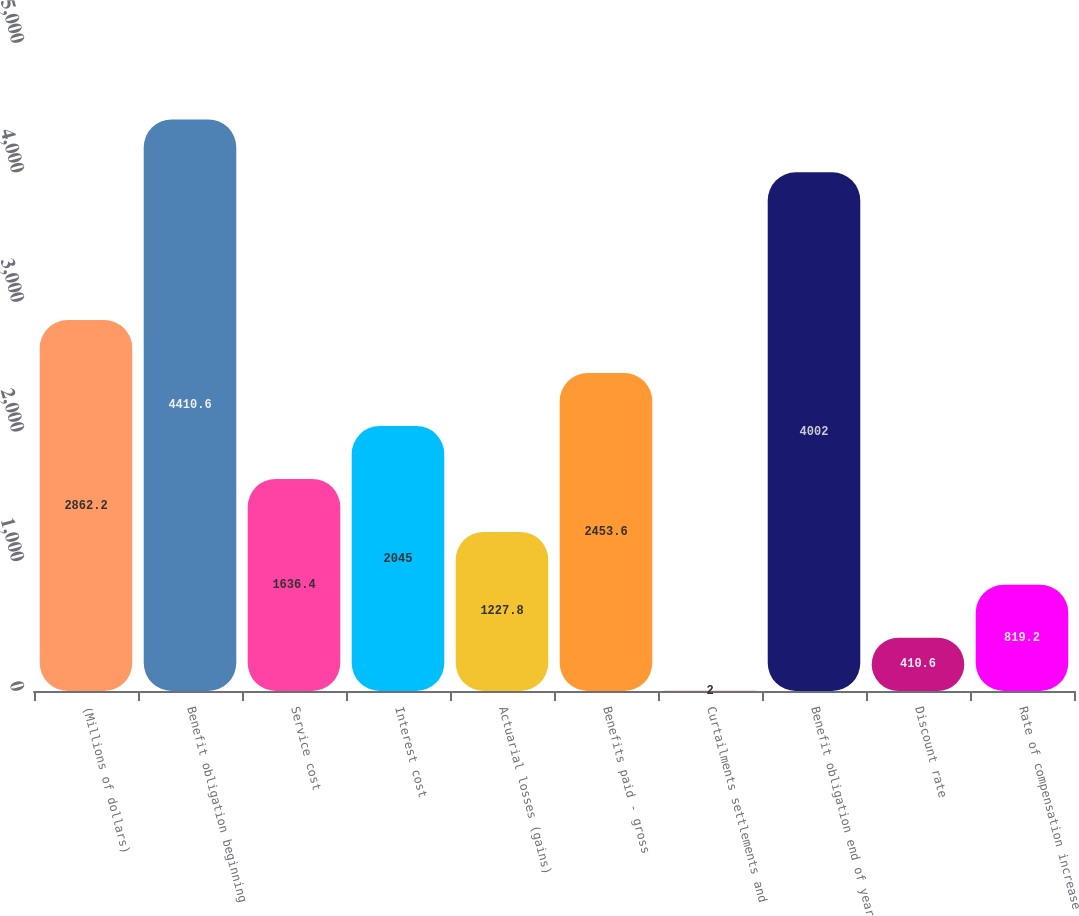Convert chart. <chart><loc_0><loc_0><loc_500><loc_500><bar_chart><fcel>(Millions of dollars)<fcel>Benefit obligation beginning<fcel>Service cost<fcel>Interest cost<fcel>Actuarial losses (gains)<fcel>Benefits paid - gross<fcel>Curtailments settlements and<fcel>Benefit obligation end of year<fcel>Discount rate<fcel>Rate of compensation increase<nl><fcel>2862.2<fcel>4410.6<fcel>1636.4<fcel>2045<fcel>1227.8<fcel>2453.6<fcel>2<fcel>4002<fcel>410.6<fcel>819.2<nl></chart> 